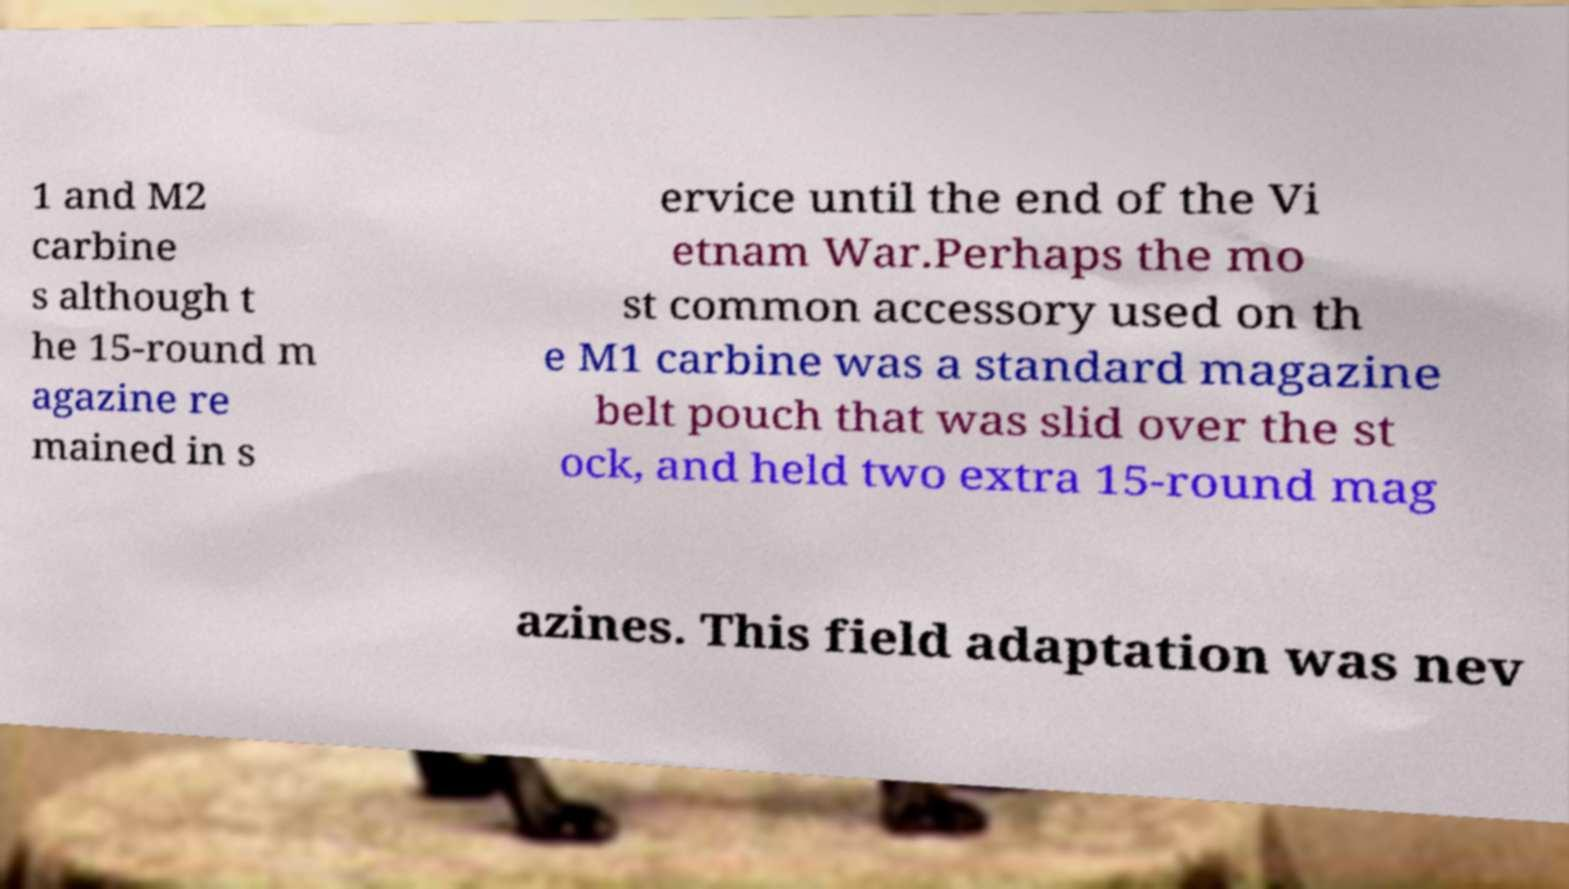Could you extract and type out the text from this image? 1 and M2 carbine s although t he 15-round m agazine re mained in s ervice until the end of the Vi etnam War.Perhaps the mo st common accessory used on th e M1 carbine was a standard magazine belt pouch that was slid over the st ock, and held two extra 15-round mag azines. This field adaptation was nev 